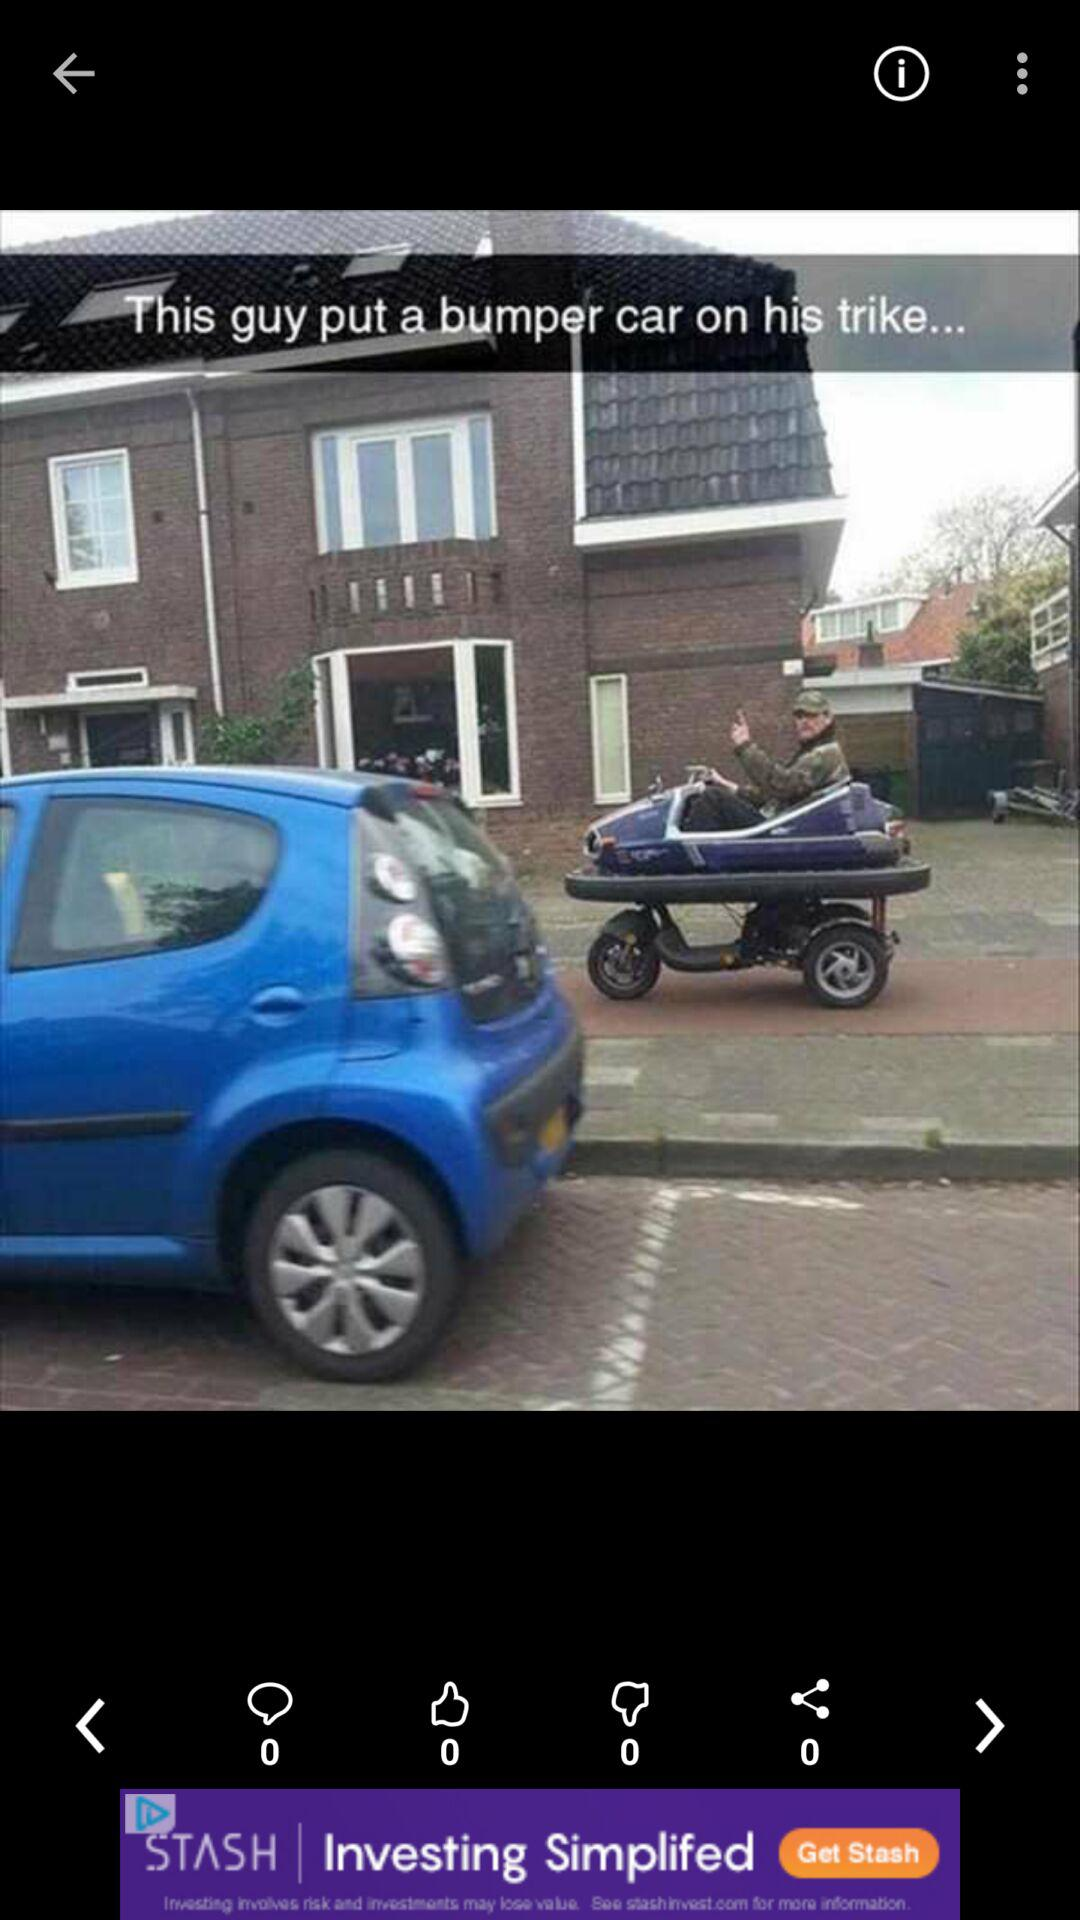What is the total count of dislikes on the post? The total count of dislikes is 0. 